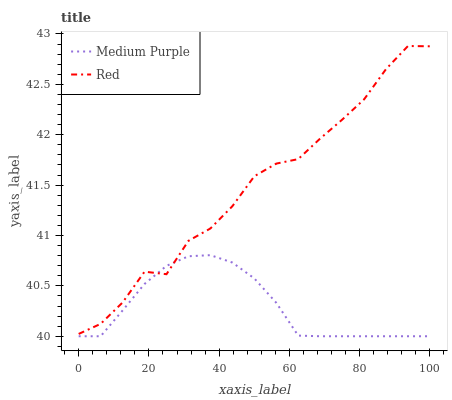Does Medium Purple have the minimum area under the curve?
Answer yes or no. Yes. Does Red have the maximum area under the curve?
Answer yes or no. Yes. Does Red have the minimum area under the curve?
Answer yes or no. No. Is Medium Purple the smoothest?
Answer yes or no. Yes. Is Red the roughest?
Answer yes or no. Yes. Is Red the smoothest?
Answer yes or no. No. Does Medium Purple have the lowest value?
Answer yes or no. Yes. Does Red have the lowest value?
Answer yes or no. No. Does Red have the highest value?
Answer yes or no. Yes. Does Red intersect Medium Purple?
Answer yes or no. Yes. Is Red less than Medium Purple?
Answer yes or no. No. Is Red greater than Medium Purple?
Answer yes or no. No. 